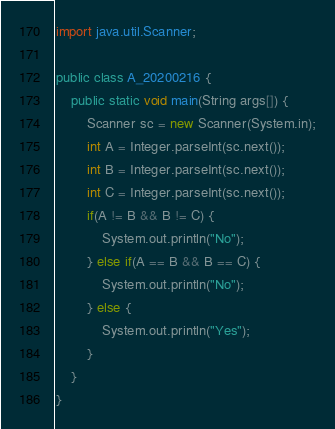<code> <loc_0><loc_0><loc_500><loc_500><_Java_>import java.util.Scanner;

public class A_20200216 {
    public static void main(String args[]) {
        Scanner sc = new Scanner(System.in);
        int A = Integer.parseInt(sc.next());
        int B = Integer.parseInt(sc.next());
        int C = Integer.parseInt(sc.next());
        if(A != B && B != C) {
            System.out.println("No");
        } else if(A == B && B == C) {
            System.out.println("No");
        } else {
            System.out.println("Yes");
        }
    }
}</code> 